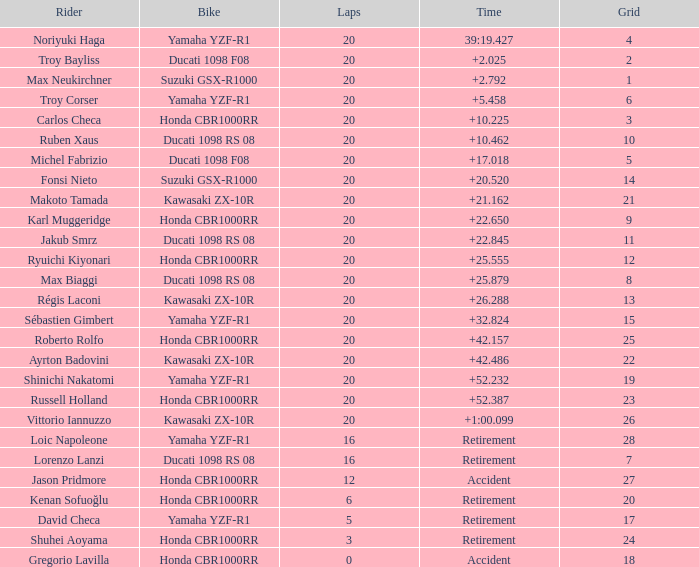What is troy bayliss' time with fewer than 8 grids? 2.025. 